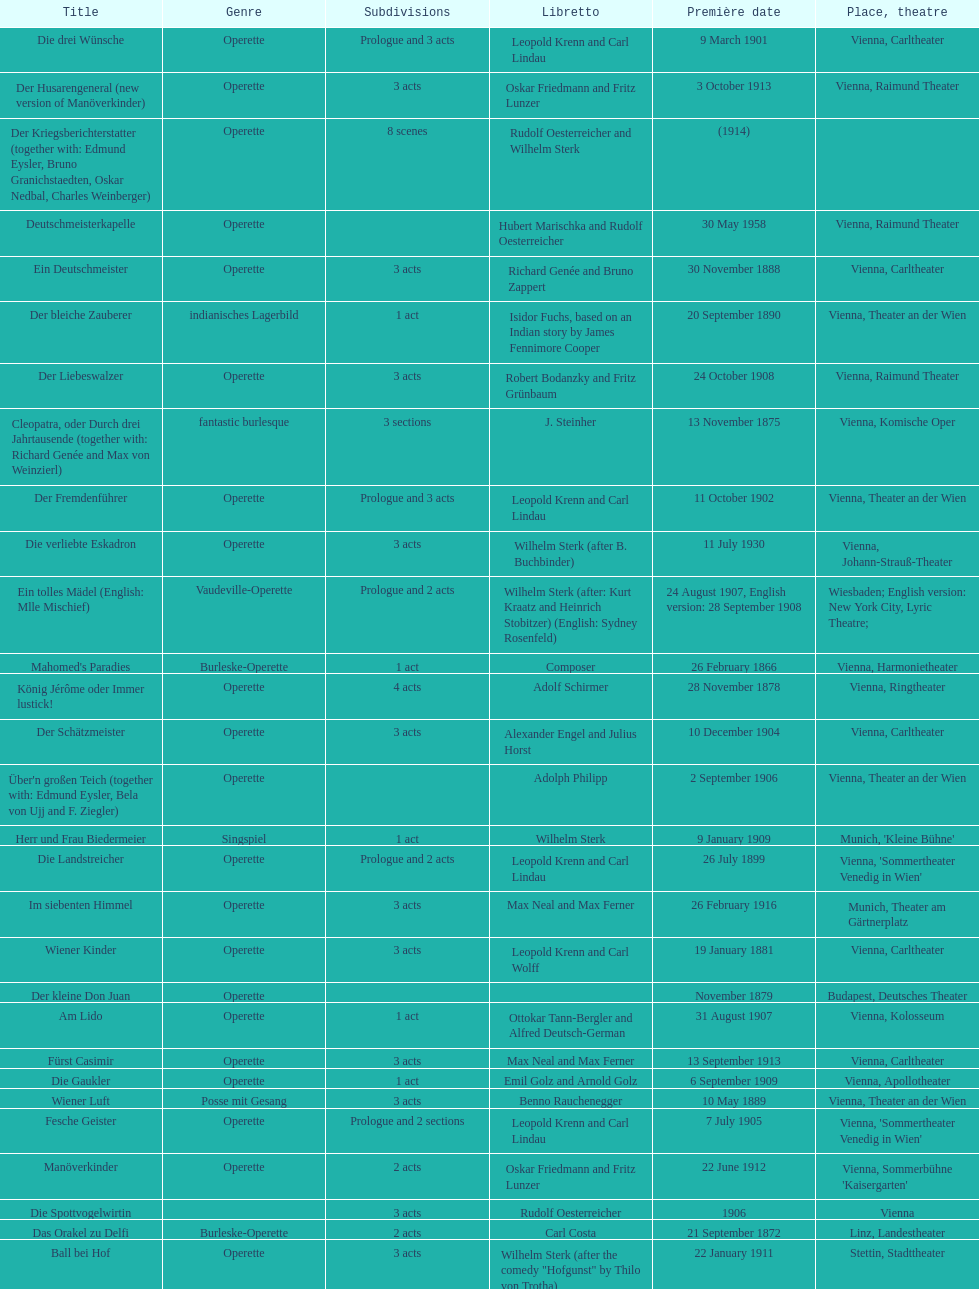In which city did the most operettas premiere? Vienna. 